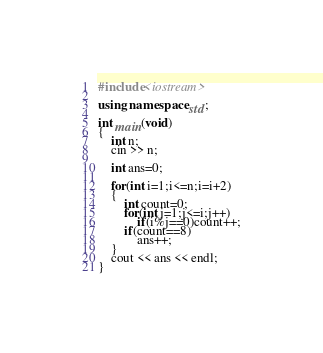<code> <loc_0><loc_0><loc_500><loc_500><_C++_>#include<iostream>

using namespace std;

int main(void)
{
	int n;
	cin >> n;

	int ans=0;

	for(int i=1;i<=n;i=i+2)
	{
		int count=0;
		for(int j=1;j<=i;j++)
			if(i%j==0)count++;
		if(count==8)
			ans++;
	}
	cout << ans << endl;
}</code> 